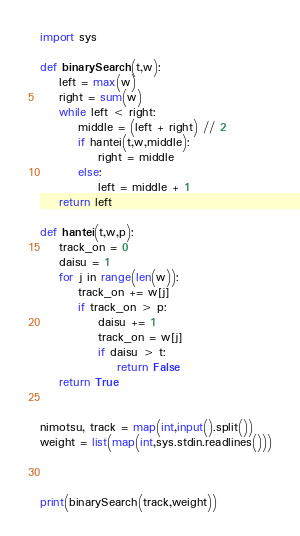Convert code to text. <code><loc_0><loc_0><loc_500><loc_500><_Python_>import sys

def binarySearch(t,w):
    left = max(w)
    right = sum(w)
    while left < right:
        middle = (left + right) // 2
        if hantei(t,w,middle):
            right = middle 
        else:
            left = middle + 1
    return left
            
def hantei(t,w,p):
    track_on = 0
    daisu = 1
    for j in range(len(w)):     
        track_on += w[j]
        if track_on > p:
            daisu += 1
            track_on = w[j]
            if daisu > t:
                return False
    return True


nimotsu, track = map(int,input().split())
weight = list(map(int,sys.stdin.readlines()))



print(binarySearch(track,weight))</code> 